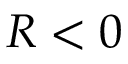Convert formula to latex. <formula><loc_0><loc_0><loc_500><loc_500>R < 0</formula> 